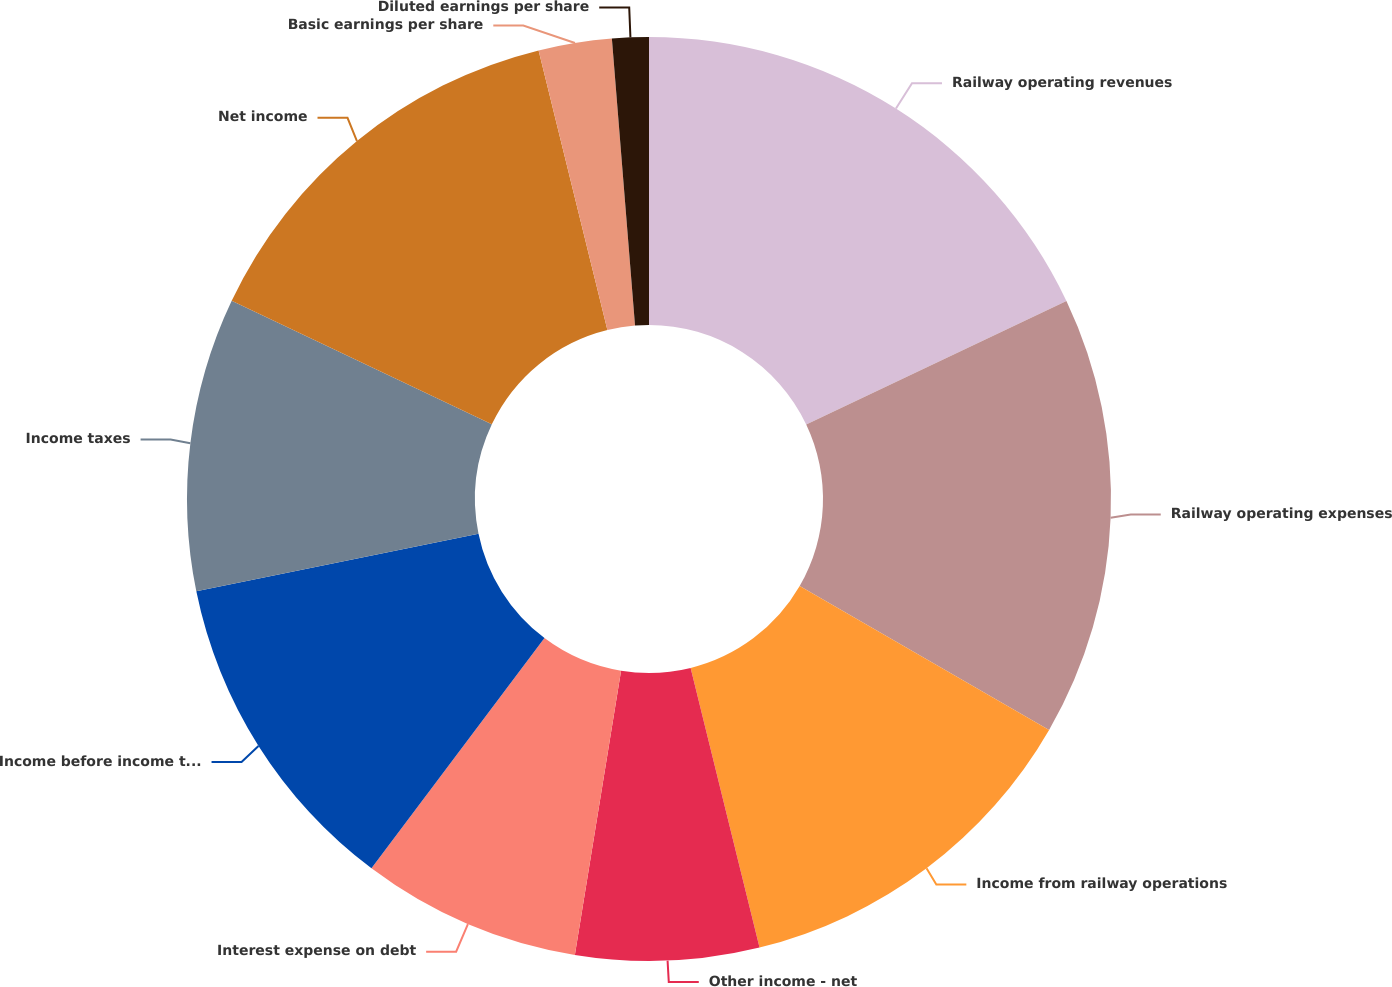<chart> <loc_0><loc_0><loc_500><loc_500><pie_chart><fcel>Railway operating revenues<fcel>Railway operating expenses<fcel>Income from railway operations<fcel>Other income - net<fcel>Interest expense on debt<fcel>Income before income taxes<fcel>Income taxes<fcel>Net income<fcel>Basic earnings per share<fcel>Diluted earnings per share<nl><fcel>17.95%<fcel>15.38%<fcel>12.82%<fcel>6.41%<fcel>7.69%<fcel>11.54%<fcel>10.26%<fcel>14.1%<fcel>2.56%<fcel>1.28%<nl></chart> 